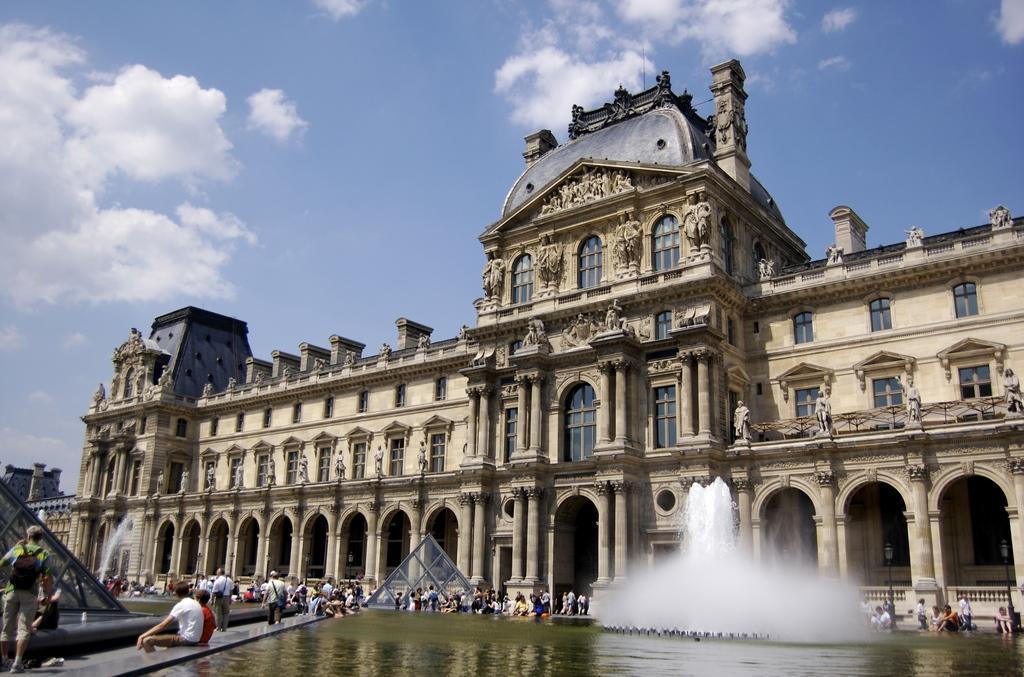Could you give a brief overview of what you see in this image? In this image I can see a building, number of windows, number of sculptures, clouds, the sky, water and water fountain over here. I can also see number of people where few are standing and few are sitting. 